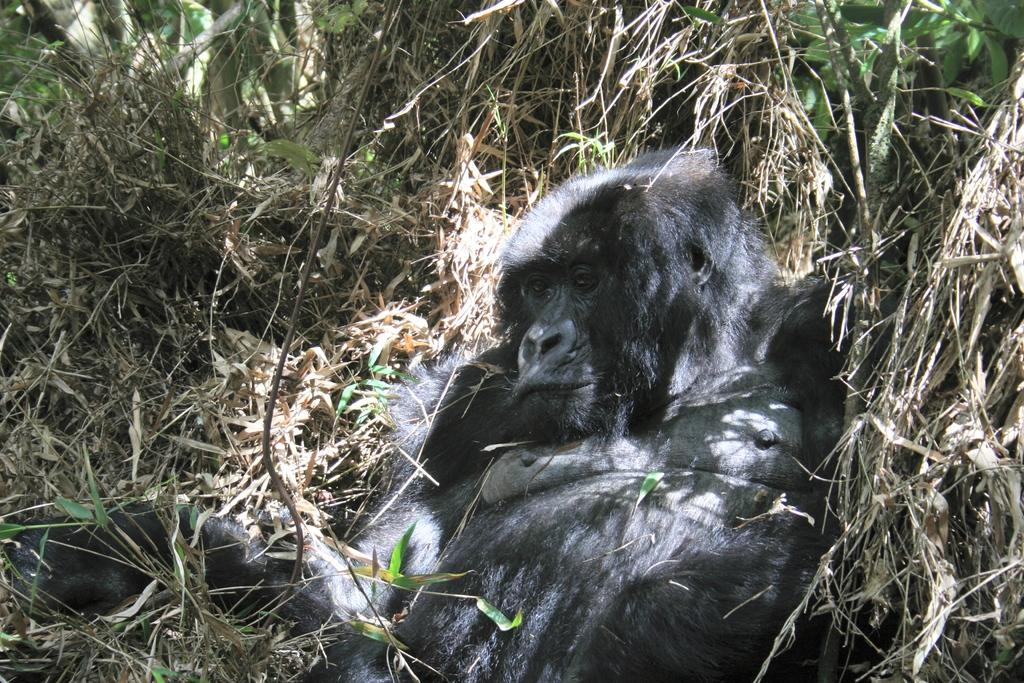What animal is the main subject of the picture? There is a gorilla in the picture. What is the gorilla's position in the image? The gorilla is lying on dry grass. What type of vegetation can be seen in the image? There are plants visible in the image. What type of cheese is the gorilla holding in the image? There is no cheese present in the image; the gorilla is lying on dry grass. grass with no visible objects in its hands. 